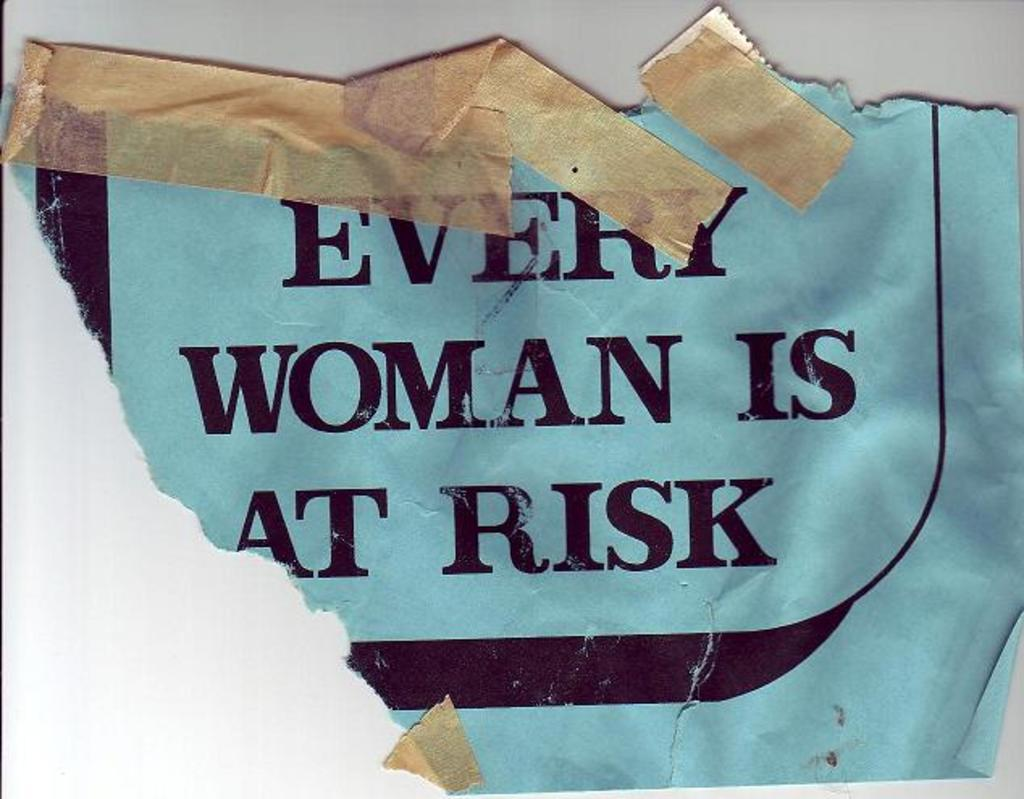<image>
Summarize the visual content of the image. blue piece of paper that is ripped in half that says "Every Woman is At Risk". 